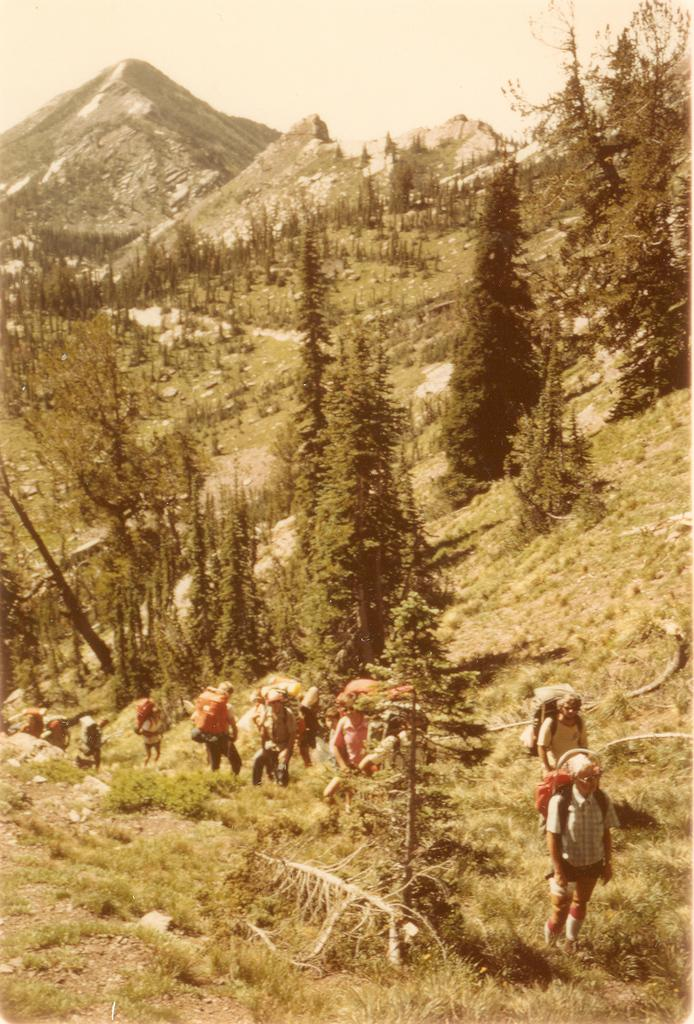What type of natural landscape is depicted in the image? The image features mountains, trees, grass, and stones, which are all elements of a natural landscape. What type of vegetation can be seen in the image? Trees and plants are visible in the image. What is the terrain like in the image? The terrain includes grass and stones. Who is present in the image? There is a group of people in the image. What are the people wearing that might be useful for carrying items? The people are wearing backpacks. How many toes are visible on the people in the image? There is no way to determine the number of toes visible on the people in the image, as their feet are not shown. What type of bed is present in the image? There is no bed present in the image; it features a natural landscape with mountains, trees, grass, and stones. 